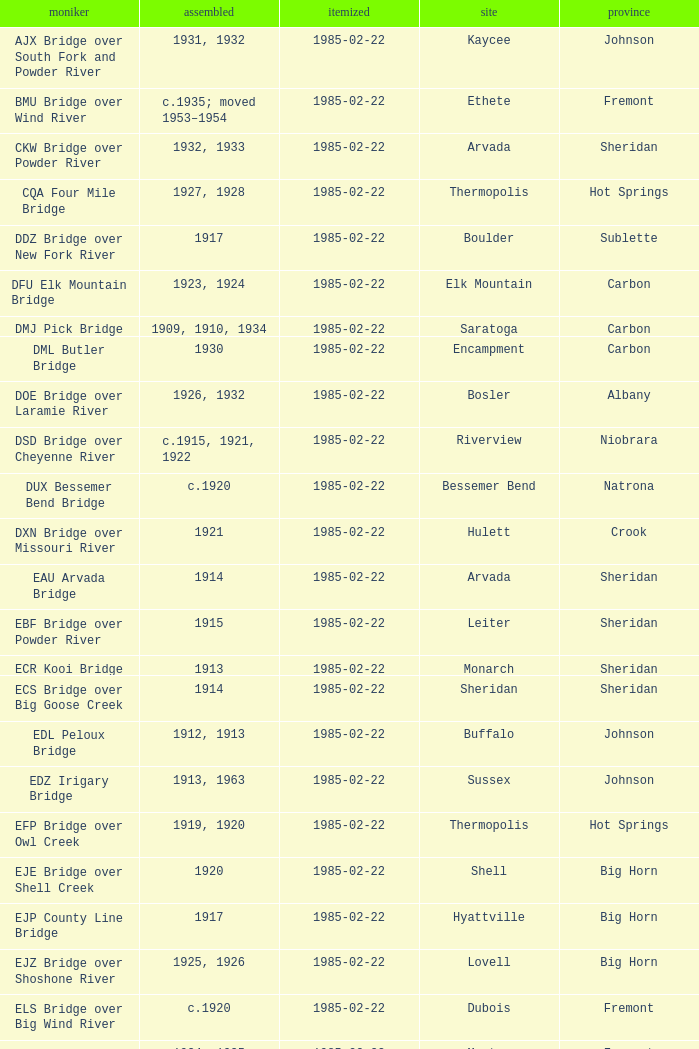In what year was the bridge in Lovell built? 1925, 1926. 